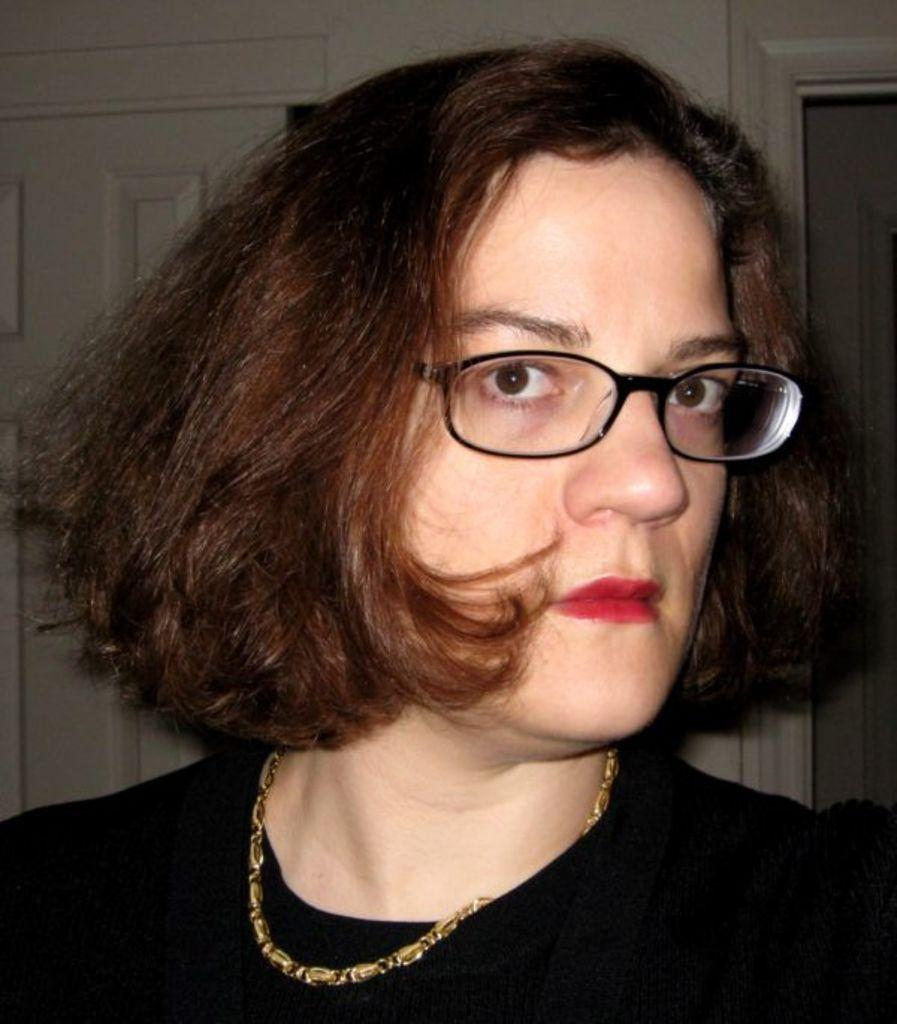Who is present in the image? There is a woman in the image. What can be seen in the background of the image? There is a wall in the background of the image. What type of oil is being used by the cat in the image? There is no cat present in the image, and therefore no oil usage can be observed. 